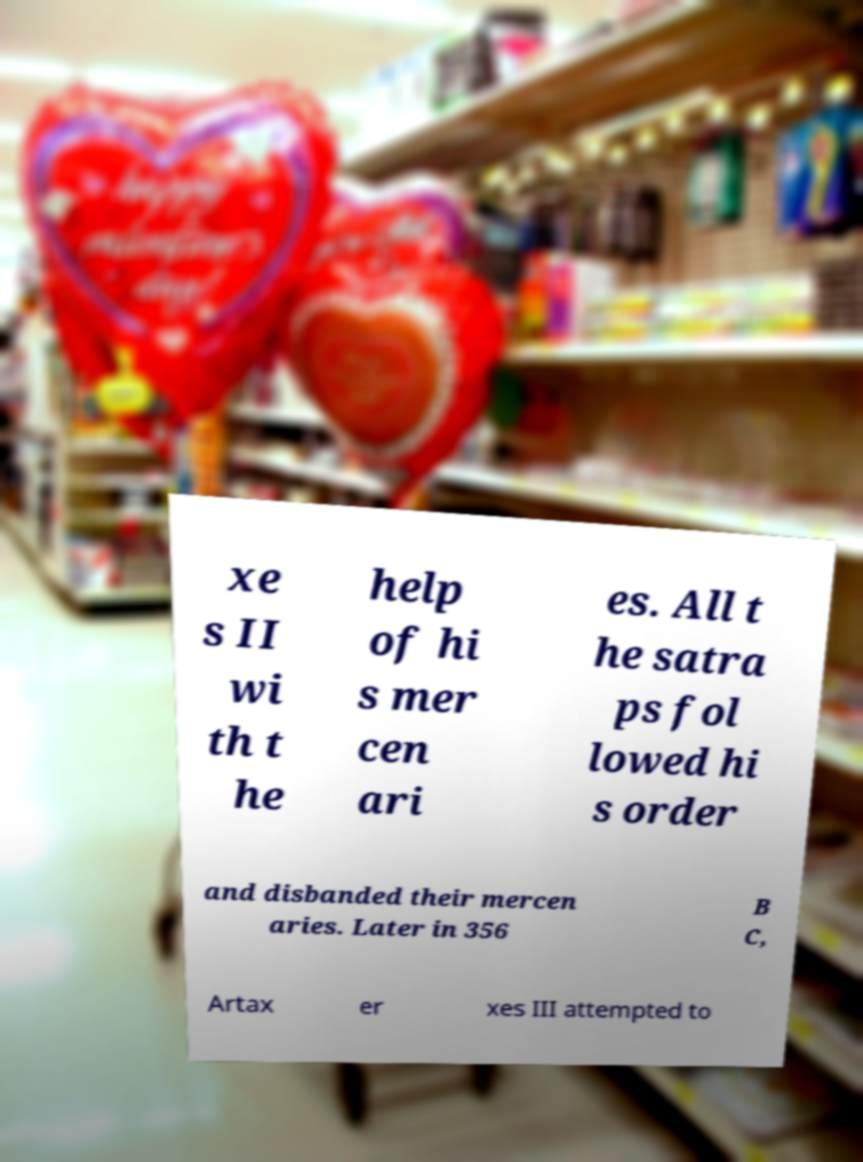Please read and relay the text visible in this image. What does it say? xe s II wi th t he help of hi s mer cen ari es. All t he satra ps fol lowed hi s order and disbanded their mercen aries. Later in 356 B C, Artax er xes III attempted to 